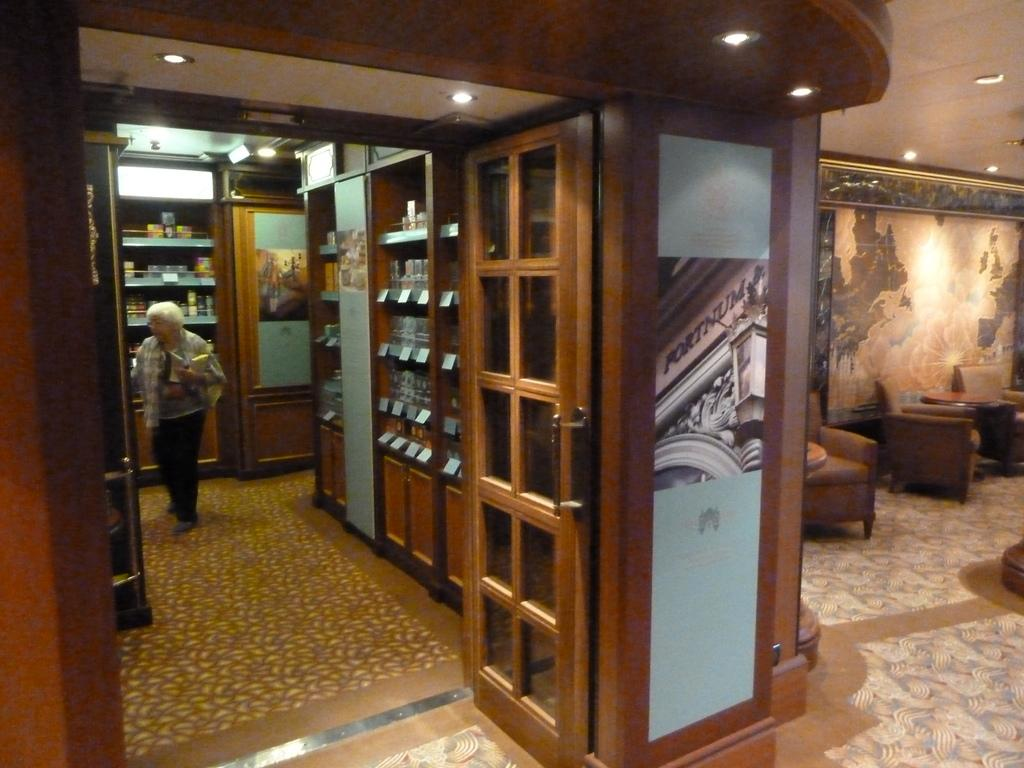What type of entryway is visible in the image? There is a door in the image. What can be seen illuminating the area in the image? There are lights in the image. What type of decorative item is present in the image? There is a photo frame in the image. What type of furniture is visible in the image? There are chairs in the image. What type of storage unit is present in the image? There are wooden drawers in the image. Is there a person in the image? Yes, there is a person standing in the image. What type of wine is being served by the maid in the image? There is no maid or wine present in the image. How many tickets are visible in the image? There are no tickets visible in the image. 